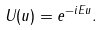<formula> <loc_0><loc_0><loc_500><loc_500>U ( u ) = e ^ { - i E u } .</formula> 